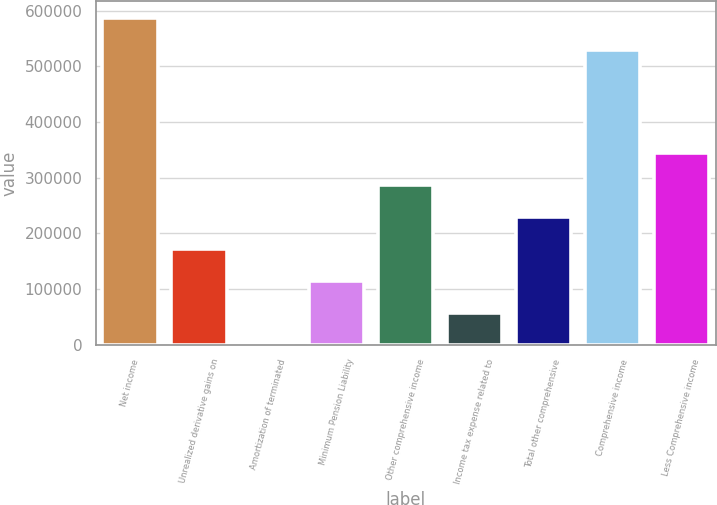Convert chart to OTSL. <chart><loc_0><loc_0><loc_500><loc_500><bar_chart><fcel>Net income<fcel>Unrealized derivative gains on<fcel>Amortization of terminated<fcel>Minimum Pension Liability<fcel>Other comprehensive income<fcel>Income tax expense related to<fcel>Total other comprehensive<fcel>Comprehensive income<fcel>Less Comprehensive income<nl><fcel>587380<fcel>172245<fcel>336<fcel>114942<fcel>286852<fcel>57639.1<fcel>229548<fcel>530077<fcel>344155<nl></chart> 